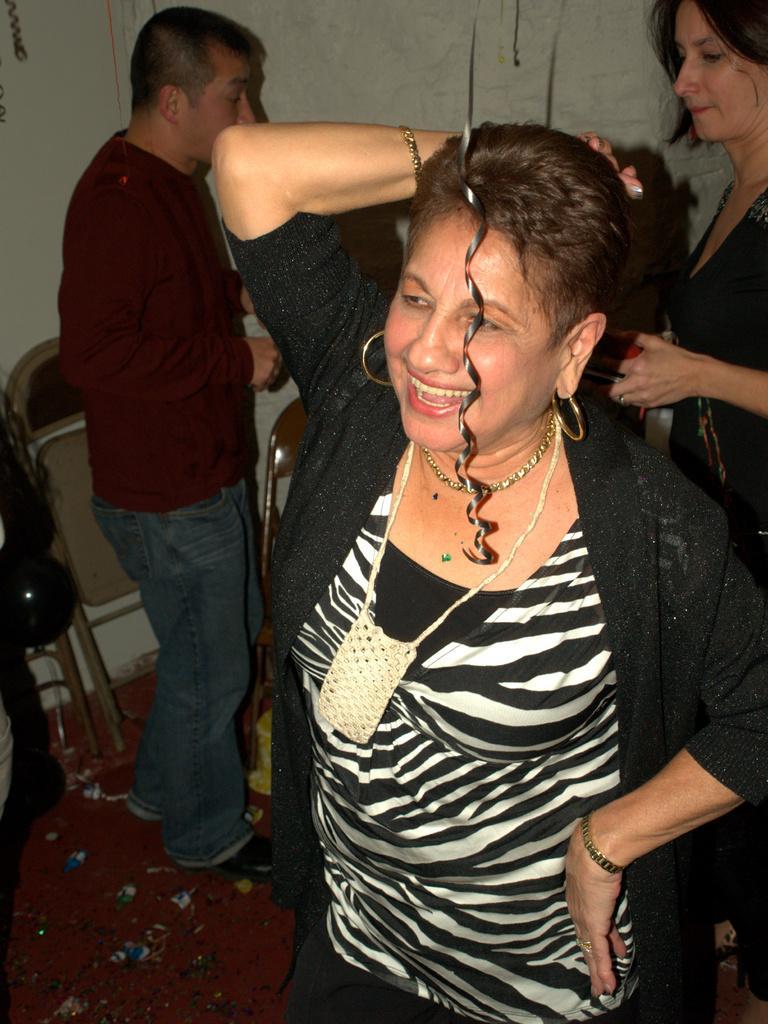Could you give a brief overview of what you see in this image? In this image we can see people standing on the floor. In the background we can see walls, chairs, confetti, balloon and carpet. 